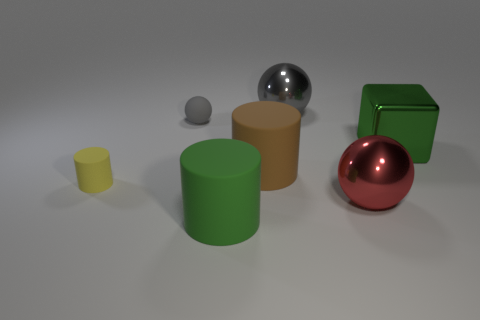There is a object that is the same color as the large cube; what is its material?
Provide a short and direct response. Rubber. Is there a red object made of the same material as the big gray sphere?
Give a very brief answer. Yes. There is a green metallic thing that is behind the matte cylinder in front of the red object; how big is it?
Your answer should be very brief. Large. Is the number of big brown things greater than the number of tiny things?
Give a very brief answer. No. Does the metal ball that is behind the block have the same size as the large red thing?
Your answer should be compact. Yes. What number of metal things are the same color as the small cylinder?
Your answer should be very brief. 0. Does the yellow rubber thing have the same shape as the large gray object?
Your response must be concise. No. Is there any other thing that is the same size as the green block?
Ensure brevity in your answer.  Yes. What size is the matte thing that is the same shape as the big red metallic thing?
Provide a succinct answer. Small. Are there more large brown objects that are behind the block than big metallic balls that are in front of the large red metal object?
Provide a short and direct response. No. 